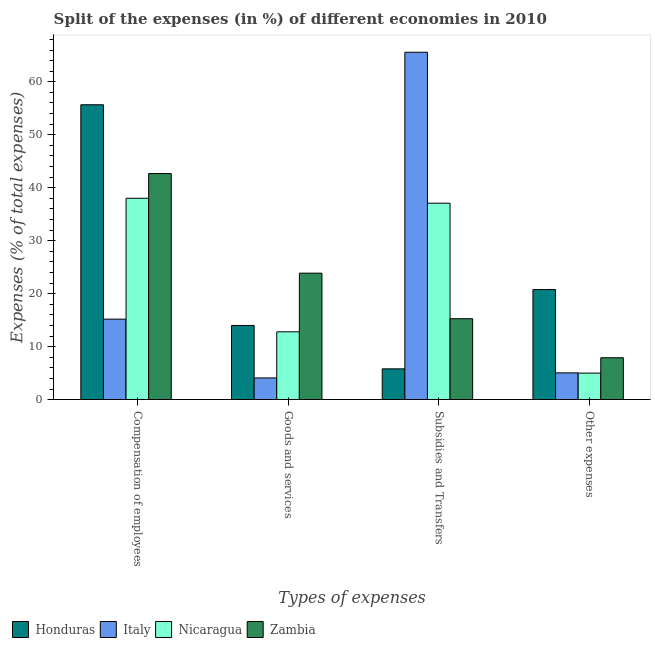How many different coloured bars are there?
Provide a short and direct response. 4. How many bars are there on the 4th tick from the left?
Your answer should be very brief. 4. What is the label of the 2nd group of bars from the left?
Your answer should be very brief. Goods and services. What is the percentage of amount spent on goods and services in Nicaragua?
Give a very brief answer. 12.8. Across all countries, what is the maximum percentage of amount spent on other expenses?
Your answer should be very brief. 20.78. Across all countries, what is the minimum percentage of amount spent on goods and services?
Give a very brief answer. 4.09. In which country was the percentage of amount spent on goods and services maximum?
Your answer should be very brief. Zambia. What is the total percentage of amount spent on compensation of employees in the graph?
Your response must be concise. 151.55. What is the difference between the percentage of amount spent on subsidies in Honduras and that in Italy?
Offer a very short reply. -59.78. What is the difference between the percentage of amount spent on subsidies in Nicaragua and the percentage of amount spent on other expenses in Honduras?
Make the answer very short. 16.3. What is the average percentage of amount spent on other expenses per country?
Provide a short and direct response. 9.68. What is the difference between the percentage of amount spent on goods and services and percentage of amount spent on compensation of employees in Honduras?
Offer a terse response. -41.67. What is the ratio of the percentage of amount spent on subsidies in Italy to that in Honduras?
Provide a succinct answer. 11.3. Is the difference between the percentage of amount spent on other expenses in Italy and Honduras greater than the difference between the percentage of amount spent on compensation of employees in Italy and Honduras?
Ensure brevity in your answer.  Yes. What is the difference between the highest and the second highest percentage of amount spent on other expenses?
Keep it short and to the point. 12.87. What is the difference between the highest and the lowest percentage of amount spent on other expenses?
Your answer should be compact. 15.77. What does the 2nd bar from the left in Compensation of employees represents?
Offer a terse response. Italy. What does the 1st bar from the right in Subsidies and Transfers represents?
Make the answer very short. Zambia. How many bars are there?
Offer a very short reply. 16. Are all the bars in the graph horizontal?
Offer a very short reply. No. What is the difference between two consecutive major ticks on the Y-axis?
Your answer should be very brief. 10. Does the graph contain any zero values?
Your answer should be compact. No. How are the legend labels stacked?
Give a very brief answer. Horizontal. What is the title of the graph?
Make the answer very short. Split of the expenses (in %) of different economies in 2010. What is the label or title of the X-axis?
Give a very brief answer. Types of expenses. What is the label or title of the Y-axis?
Offer a terse response. Expenses (% of total expenses). What is the Expenses (% of total expenses) of Honduras in Compensation of employees?
Your answer should be compact. 55.67. What is the Expenses (% of total expenses) in Italy in Compensation of employees?
Keep it short and to the point. 15.19. What is the Expenses (% of total expenses) in Nicaragua in Compensation of employees?
Provide a succinct answer. 38.01. What is the Expenses (% of total expenses) in Zambia in Compensation of employees?
Make the answer very short. 42.68. What is the Expenses (% of total expenses) in Honduras in Goods and services?
Your response must be concise. 14. What is the Expenses (% of total expenses) in Italy in Goods and services?
Ensure brevity in your answer.  4.09. What is the Expenses (% of total expenses) in Nicaragua in Goods and services?
Ensure brevity in your answer.  12.8. What is the Expenses (% of total expenses) of Zambia in Goods and services?
Your answer should be compact. 23.87. What is the Expenses (% of total expenses) of Honduras in Subsidies and Transfers?
Offer a terse response. 5.81. What is the Expenses (% of total expenses) in Italy in Subsidies and Transfers?
Offer a very short reply. 65.58. What is the Expenses (% of total expenses) in Nicaragua in Subsidies and Transfers?
Your response must be concise. 37.08. What is the Expenses (% of total expenses) of Zambia in Subsidies and Transfers?
Ensure brevity in your answer.  15.27. What is the Expenses (% of total expenses) of Honduras in Other expenses?
Your response must be concise. 20.78. What is the Expenses (% of total expenses) of Italy in Other expenses?
Ensure brevity in your answer.  5.05. What is the Expenses (% of total expenses) of Nicaragua in Other expenses?
Ensure brevity in your answer.  5. What is the Expenses (% of total expenses) in Zambia in Other expenses?
Offer a very short reply. 7.9. Across all Types of expenses, what is the maximum Expenses (% of total expenses) in Honduras?
Your response must be concise. 55.67. Across all Types of expenses, what is the maximum Expenses (% of total expenses) in Italy?
Ensure brevity in your answer.  65.58. Across all Types of expenses, what is the maximum Expenses (% of total expenses) of Nicaragua?
Your answer should be very brief. 38.01. Across all Types of expenses, what is the maximum Expenses (% of total expenses) in Zambia?
Make the answer very short. 42.68. Across all Types of expenses, what is the minimum Expenses (% of total expenses) in Honduras?
Give a very brief answer. 5.81. Across all Types of expenses, what is the minimum Expenses (% of total expenses) of Italy?
Offer a terse response. 4.09. Across all Types of expenses, what is the minimum Expenses (% of total expenses) in Nicaragua?
Your response must be concise. 5. Across all Types of expenses, what is the minimum Expenses (% of total expenses) of Zambia?
Give a very brief answer. 7.9. What is the total Expenses (% of total expenses) in Honduras in the graph?
Your response must be concise. 96.25. What is the total Expenses (% of total expenses) of Italy in the graph?
Offer a terse response. 89.91. What is the total Expenses (% of total expenses) in Nicaragua in the graph?
Your response must be concise. 92.9. What is the total Expenses (% of total expenses) of Zambia in the graph?
Give a very brief answer. 89.73. What is the difference between the Expenses (% of total expenses) of Honduras in Compensation of employees and that in Goods and services?
Offer a terse response. 41.67. What is the difference between the Expenses (% of total expenses) in Italy in Compensation of employees and that in Goods and services?
Offer a terse response. 11.1. What is the difference between the Expenses (% of total expenses) of Nicaragua in Compensation of employees and that in Goods and services?
Provide a short and direct response. 25.21. What is the difference between the Expenses (% of total expenses) in Zambia in Compensation of employees and that in Goods and services?
Your answer should be very brief. 18.8. What is the difference between the Expenses (% of total expenses) in Honduras in Compensation of employees and that in Subsidies and Transfers?
Make the answer very short. 49.86. What is the difference between the Expenses (% of total expenses) in Italy in Compensation of employees and that in Subsidies and Transfers?
Your answer should be compact. -50.39. What is the difference between the Expenses (% of total expenses) of Nicaragua in Compensation of employees and that in Subsidies and Transfers?
Your answer should be very brief. 0.93. What is the difference between the Expenses (% of total expenses) in Zambia in Compensation of employees and that in Subsidies and Transfers?
Your answer should be very brief. 27.4. What is the difference between the Expenses (% of total expenses) of Honduras in Compensation of employees and that in Other expenses?
Give a very brief answer. 34.89. What is the difference between the Expenses (% of total expenses) in Italy in Compensation of employees and that in Other expenses?
Give a very brief answer. 10.14. What is the difference between the Expenses (% of total expenses) in Nicaragua in Compensation of employees and that in Other expenses?
Your response must be concise. 33.01. What is the difference between the Expenses (% of total expenses) of Zambia in Compensation of employees and that in Other expenses?
Offer a terse response. 34.77. What is the difference between the Expenses (% of total expenses) of Honduras in Goods and services and that in Subsidies and Transfers?
Your response must be concise. 8.19. What is the difference between the Expenses (% of total expenses) of Italy in Goods and services and that in Subsidies and Transfers?
Your answer should be compact. -61.49. What is the difference between the Expenses (% of total expenses) of Nicaragua in Goods and services and that in Subsidies and Transfers?
Keep it short and to the point. -24.28. What is the difference between the Expenses (% of total expenses) in Zambia in Goods and services and that in Subsidies and Transfers?
Ensure brevity in your answer.  8.6. What is the difference between the Expenses (% of total expenses) in Honduras in Goods and services and that in Other expenses?
Your answer should be compact. -6.78. What is the difference between the Expenses (% of total expenses) in Italy in Goods and services and that in Other expenses?
Provide a succinct answer. -0.96. What is the difference between the Expenses (% of total expenses) of Nicaragua in Goods and services and that in Other expenses?
Make the answer very short. 7.8. What is the difference between the Expenses (% of total expenses) of Zambia in Goods and services and that in Other expenses?
Ensure brevity in your answer.  15.97. What is the difference between the Expenses (% of total expenses) of Honduras in Subsidies and Transfers and that in Other expenses?
Give a very brief answer. -14.97. What is the difference between the Expenses (% of total expenses) in Italy in Subsidies and Transfers and that in Other expenses?
Make the answer very short. 60.53. What is the difference between the Expenses (% of total expenses) of Nicaragua in Subsidies and Transfers and that in Other expenses?
Provide a short and direct response. 32.08. What is the difference between the Expenses (% of total expenses) of Zambia in Subsidies and Transfers and that in Other expenses?
Your answer should be very brief. 7.37. What is the difference between the Expenses (% of total expenses) in Honduras in Compensation of employees and the Expenses (% of total expenses) in Italy in Goods and services?
Make the answer very short. 51.58. What is the difference between the Expenses (% of total expenses) in Honduras in Compensation of employees and the Expenses (% of total expenses) in Nicaragua in Goods and services?
Your answer should be very brief. 42.86. What is the difference between the Expenses (% of total expenses) of Honduras in Compensation of employees and the Expenses (% of total expenses) of Zambia in Goods and services?
Your answer should be compact. 31.79. What is the difference between the Expenses (% of total expenses) in Italy in Compensation of employees and the Expenses (% of total expenses) in Nicaragua in Goods and services?
Provide a succinct answer. 2.39. What is the difference between the Expenses (% of total expenses) of Italy in Compensation of employees and the Expenses (% of total expenses) of Zambia in Goods and services?
Make the answer very short. -8.68. What is the difference between the Expenses (% of total expenses) of Nicaragua in Compensation of employees and the Expenses (% of total expenses) of Zambia in Goods and services?
Make the answer very short. 14.14. What is the difference between the Expenses (% of total expenses) of Honduras in Compensation of employees and the Expenses (% of total expenses) of Italy in Subsidies and Transfers?
Ensure brevity in your answer.  -9.91. What is the difference between the Expenses (% of total expenses) in Honduras in Compensation of employees and the Expenses (% of total expenses) in Nicaragua in Subsidies and Transfers?
Give a very brief answer. 18.58. What is the difference between the Expenses (% of total expenses) in Honduras in Compensation of employees and the Expenses (% of total expenses) in Zambia in Subsidies and Transfers?
Make the answer very short. 40.39. What is the difference between the Expenses (% of total expenses) of Italy in Compensation of employees and the Expenses (% of total expenses) of Nicaragua in Subsidies and Transfers?
Make the answer very short. -21.89. What is the difference between the Expenses (% of total expenses) of Italy in Compensation of employees and the Expenses (% of total expenses) of Zambia in Subsidies and Transfers?
Your answer should be very brief. -0.08. What is the difference between the Expenses (% of total expenses) in Nicaragua in Compensation of employees and the Expenses (% of total expenses) in Zambia in Subsidies and Transfers?
Your answer should be very brief. 22.74. What is the difference between the Expenses (% of total expenses) in Honduras in Compensation of employees and the Expenses (% of total expenses) in Italy in Other expenses?
Keep it short and to the point. 50.62. What is the difference between the Expenses (% of total expenses) in Honduras in Compensation of employees and the Expenses (% of total expenses) in Nicaragua in Other expenses?
Give a very brief answer. 50.66. What is the difference between the Expenses (% of total expenses) in Honduras in Compensation of employees and the Expenses (% of total expenses) in Zambia in Other expenses?
Keep it short and to the point. 47.76. What is the difference between the Expenses (% of total expenses) in Italy in Compensation of employees and the Expenses (% of total expenses) in Nicaragua in Other expenses?
Give a very brief answer. 10.19. What is the difference between the Expenses (% of total expenses) of Italy in Compensation of employees and the Expenses (% of total expenses) of Zambia in Other expenses?
Provide a succinct answer. 7.29. What is the difference between the Expenses (% of total expenses) of Nicaragua in Compensation of employees and the Expenses (% of total expenses) of Zambia in Other expenses?
Make the answer very short. 30.11. What is the difference between the Expenses (% of total expenses) of Honduras in Goods and services and the Expenses (% of total expenses) of Italy in Subsidies and Transfers?
Keep it short and to the point. -51.58. What is the difference between the Expenses (% of total expenses) of Honduras in Goods and services and the Expenses (% of total expenses) of Nicaragua in Subsidies and Transfers?
Offer a terse response. -23.08. What is the difference between the Expenses (% of total expenses) of Honduras in Goods and services and the Expenses (% of total expenses) of Zambia in Subsidies and Transfers?
Your answer should be very brief. -1.28. What is the difference between the Expenses (% of total expenses) in Italy in Goods and services and the Expenses (% of total expenses) in Nicaragua in Subsidies and Transfers?
Your answer should be compact. -32.99. What is the difference between the Expenses (% of total expenses) of Italy in Goods and services and the Expenses (% of total expenses) of Zambia in Subsidies and Transfers?
Provide a short and direct response. -11.18. What is the difference between the Expenses (% of total expenses) in Nicaragua in Goods and services and the Expenses (% of total expenses) in Zambia in Subsidies and Transfers?
Your answer should be compact. -2.47. What is the difference between the Expenses (% of total expenses) in Honduras in Goods and services and the Expenses (% of total expenses) in Italy in Other expenses?
Give a very brief answer. 8.95. What is the difference between the Expenses (% of total expenses) of Honduras in Goods and services and the Expenses (% of total expenses) of Nicaragua in Other expenses?
Your answer should be very brief. 8.99. What is the difference between the Expenses (% of total expenses) of Honduras in Goods and services and the Expenses (% of total expenses) of Zambia in Other expenses?
Ensure brevity in your answer.  6.09. What is the difference between the Expenses (% of total expenses) of Italy in Goods and services and the Expenses (% of total expenses) of Nicaragua in Other expenses?
Keep it short and to the point. -0.91. What is the difference between the Expenses (% of total expenses) of Italy in Goods and services and the Expenses (% of total expenses) of Zambia in Other expenses?
Provide a short and direct response. -3.81. What is the difference between the Expenses (% of total expenses) of Nicaragua in Goods and services and the Expenses (% of total expenses) of Zambia in Other expenses?
Keep it short and to the point. 4.9. What is the difference between the Expenses (% of total expenses) in Honduras in Subsidies and Transfers and the Expenses (% of total expenses) in Italy in Other expenses?
Make the answer very short. 0.76. What is the difference between the Expenses (% of total expenses) of Honduras in Subsidies and Transfers and the Expenses (% of total expenses) of Nicaragua in Other expenses?
Provide a short and direct response. 0.8. What is the difference between the Expenses (% of total expenses) in Honduras in Subsidies and Transfers and the Expenses (% of total expenses) in Zambia in Other expenses?
Offer a very short reply. -2.1. What is the difference between the Expenses (% of total expenses) in Italy in Subsidies and Transfers and the Expenses (% of total expenses) in Nicaragua in Other expenses?
Offer a terse response. 60.58. What is the difference between the Expenses (% of total expenses) of Italy in Subsidies and Transfers and the Expenses (% of total expenses) of Zambia in Other expenses?
Offer a terse response. 57.68. What is the difference between the Expenses (% of total expenses) in Nicaragua in Subsidies and Transfers and the Expenses (% of total expenses) in Zambia in Other expenses?
Make the answer very short. 29.18. What is the average Expenses (% of total expenses) of Honduras per Types of expenses?
Ensure brevity in your answer.  24.06. What is the average Expenses (% of total expenses) in Italy per Types of expenses?
Keep it short and to the point. 22.48. What is the average Expenses (% of total expenses) of Nicaragua per Types of expenses?
Keep it short and to the point. 23.23. What is the average Expenses (% of total expenses) in Zambia per Types of expenses?
Ensure brevity in your answer.  22.43. What is the difference between the Expenses (% of total expenses) in Honduras and Expenses (% of total expenses) in Italy in Compensation of employees?
Ensure brevity in your answer.  40.47. What is the difference between the Expenses (% of total expenses) of Honduras and Expenses (% of total expenses) of Nicaragua in Compensation of employees?
Your answer should be very brief. 17.65. What is the difference between the Expenses (% of total expenses) of Honduras and Expenses (% of total expenses) of Zambia in Compensation of employees?
Your answer should be very brief. 12.99. What is the difference between the Expenses (% of total expenses) in Italy and Expenses (% of total expenses) in Nicaragua in Compensation of employees?
Make the answer very short. -22.82. What is the difference between the Expenses (% of total expenses) in Italy and Expenses (% of total expenses) in Zambia in Compensation of employees?
Make the answer very short. -27.48. What is the difference between the Expenses (% of total expenses) of Nicaragua and Expenses (% of total expenses) of Zambia in Compensation of employees?
Keep it short and to the point. -4.66. What is the difference between the Expenses (% of total expenses) of Honduras and Expenses (% of total expenses) of Italy in Goods and services?
Provide a short and direct response. 9.91. What is the difference between the Expenses (% of total expenses) of Honduras and Expenses (% of total expenses) of Nicaragua in Goods and services?
Provide a succinct answer. 1.2. What is the difference between the Expenses (% of total expenses) in Honduras and Expenses (% of total expenses) in Zambia in Goods and services?
Give a very brief answer. -9.88. What is the difference between the Expenses (% of total expenses) of Italy and Expenses (% of total expenses) of Nicaragua in Goods and services?
Your response must be concise. -8.71. What is the difference between the Expenses (% of total expenses) of Italy and Expenses (% of total expenses) of Zambia in Goods and services?
Provide a succinct answer. -19.78. What is the difference between the Expenses (% of total expenses) in Nicaragua and Expenses (% of total expenses) in Zambia in Goods and services?
Ensure brevity in your answer.  -11.07. What is the difference between the Expenses (% of total expenses) in Honduras and Expenses (% of total expenses) in Italy in Subsidies and Transfers?
Ensure brevity in your answer.  -59.78. What is the difference between the Expenses (% of total expenses) of Honduras and Expenses (% of total expenses) of Nicaragua in Subsidies and Transfers?
Your answer should be very brief. -31.28. What is the difference between the Expenses (% of total expenses) in Honduras and Expenses (% of total expenses) in Zambia in Subsidies and Transfers?
Your response must be concise. -9.47. What is the difference between the Expenses (% of total expenses) of Italy and Expenses (% of total expenses) of Nicaragua in Subsidies and Transfers?
Give a very brief answer. 28.5. What is the difference between the Expenses (% of total expenses) of Italy and Expenses (% of total expenses) of Zambia in Subsidies and Transfers?
Your answer should be very brief. 50.31. What is the difference between the Expenses (% of total expenses) of Nicaragua and Expenses (% of total expenses) of Zambia in Subsidies and Transfers?
Your answer should be very brief. 21.81. What is the difference between the Expenses (% of total expenses) in Honduras and Expenses (% of total expenses) in Italy in Other expenses?
Your response must be concise. 15.73. What is the difference between the Expenses (% of total expenses) of Honduras and Expenses (% of total expenses) of Nicaragua in Other expenses?
Your answer should be compact. 15.77. What is the difference between the Expenses (% of total expenses) of Honduras and Expenses (% of total expenses) of Zambia in Other expenses?
Make the answer very short. 12.87. What is the difference between the Expenses (% of total expenses) of Italy and Expenses (% of total expenses) of Nicaragua in Other expenses?
Your response must be concise. 0.04. What is the difference between the Expenses (% of total expenses) of Italy and Expenses (% of total expenses) of Zambia in Other expenses?
Provide a succinct answer. -2.86. What is the difference between the Expenses (% of total expenses) in Nicaragua and Expenses (% of total expenses) in Zambia in Other expenses?
Your answer should be very brief. -2.9. What is the ratio of the Expenses (% of total expenses) of Honduras in Compensation of employees to that in Goods and services?
Ensure brevity in your answer.  3.98. What is the ratio of the Expenses (% of total expenses) in Italy in Compensation of employees to that in Goods and services?
Offer a terse response. 3.71. What is the ratio of the Expenses (% of total expenses) in Nicaragua in Compensation of employees to that in Goods and services?
Make the answer very short. 2.97. What is the ratio of the Expenses (% of total expenses) in Zambia in Compensation of employees to that in Goods and services?
Offer a terse response. 1.79. What is the ratio of the Expenses (% of total expenses) of Honduras in Compensation of employees to that in Subsidies and Transfers?
Provide a succinct answer. 9.59. What is the ratio of the Expenses (% of total expenses) of Italy in Compensation of employees to that in Subsidies and Transfers?
Your answer should be compact. 0.23. What is the ratio of the Expenses (% of total expenses) in Nicaragua in Compensation of employees to that in Subsidies and Transfers?
Provide a succinct answer. 1.03. What is the ratio of the Expenses (% of total expenses) of Zambia in Compensation of employees to that in Subsidies and Transfers?
Give a very brief answer. 2.79. What is the ratio of the Expenses (% of total expenses) of Honduras in Compensation of employees to that in Other expenses?
Offer a very short reply. 2.68. What is the ratio of the Expenses (% of total expenses) in Italy in Compensation of employees to that in Other expenses?
Ensure brevity in your answer.  3.01. What is the ratio of the Expenses (% of total expenses) in Nicaragua in Compensation of employees to that in Other expenses?
Your answer should be compact. 7.6. What is the ratio of the Expenses (% of total expenses) of Zambia in Compensation of employees to that in Other expenses?
Offer a terse response. 5.4. What is the ratio of the Expenses (% of total expenses) of Honduras in Goods and services to that in Subsidies and Transfers?
Offer a very short reply. 2.41. What is the ratio of the Expenses (% of total expenses) of Italy in Goods and services to that in Subsidies and Transfers?
Make the answer very short. 0.06. What is the ratio of the Expenses (% of total expenses) of Nicaragua in Goods and services to that in Subsidies and Transfers?
Give a very brief answer. 0.35. What is the ratio of the Expenses (% of total expenses) in Zambia in Goods and services to that in Subsidies and Transfers?
Offer a terse response. 1.56. What is the ratio of the Expenses (% of total expenses) of Honduras in Goods and services to that in Other expenses?
Keep it short and to the point. 0.67. What is the ratio of the Expenses (% of total expenses) in Italy in Goods and services to that in Other expenses?
Keep it short and to the point. 0.81. What is the ratio of the Expenses (% of total expenses) of Nicaragua in Goods and services to that in Other expenses?
Your answer should be compact. 2.56. What is the ratio of the Expenses (% of total expenses) of Zambia in Goods and services to that in Other expenses?
Your answer should be compact. 3.02. What is the ratio of the Expenses (% of total expenses) of Honduras in Subsidies and Transfers to that in Other expenses?
Your answer should be compact. 0.28. What is the ratio of the Expenses (% of total expenses) in Italy in Subsidies and Transfers to that in Other expenses?
Your answer should be compact. 12.99. What is the ratio of the Expenses (% of total expenses) in Nicaragua in Subsidies and Transfers to that in Other expenses?
Ensure brevity in your answer.  7.41. What is the ratio of the Expenses (% of total expenses) in Zambia in Subsidies and Transfers to that in Other expenses?
Your answer should be very brief. 1.93. What is the difference between the highest and the second highest Expenses (% of total expenses) in Honduras?
Offer a very short reply. 34.89. What is the difference between the highest and the second highest Expenses (% of total expenses) in Italy?
Ensure brevity in your answer.  50.39. What is the difference between the highest and the second highest Expenses (% of total expenses) in Nicaragua?
Offer a terse response. 0.93. What is the difference between the highest and the second highest Expenses (% of total expenses) of Zambia?
Give a very brief answer. 18.8. What is the difference between the highest and the lowest Expenses (% of total expenses) in Honduras?
Make the answer very short. 49.86. What is the difference between the highest and the lowest Expenses (% of total expenses) of Italy?
Your answer should be very brief. 61.49. What is the difference between the highest and the lowest Expenses (% of total expenses) of Nicaragua?
Your response must be concise. 33.01. What is the difference between the highest and the lowest Expenses (% of total expenses) in Zambia?
Provide a succinct answer. 34.77. 